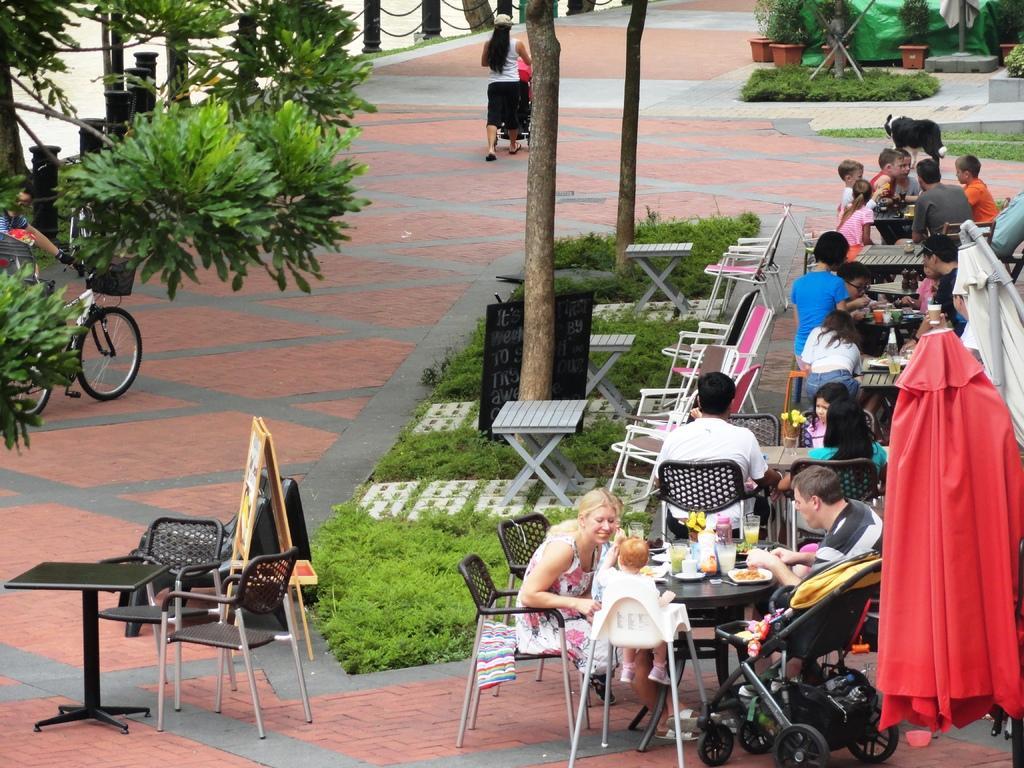How would you summarize this image in a sentence or two? In this image we can see a few people who are sitting on a chair and they are having food. Here we can see a woman walking on the sideways of a road. There is a person holding a bicycle and he is on the left side. Here we can see clay pots on the top right side. 